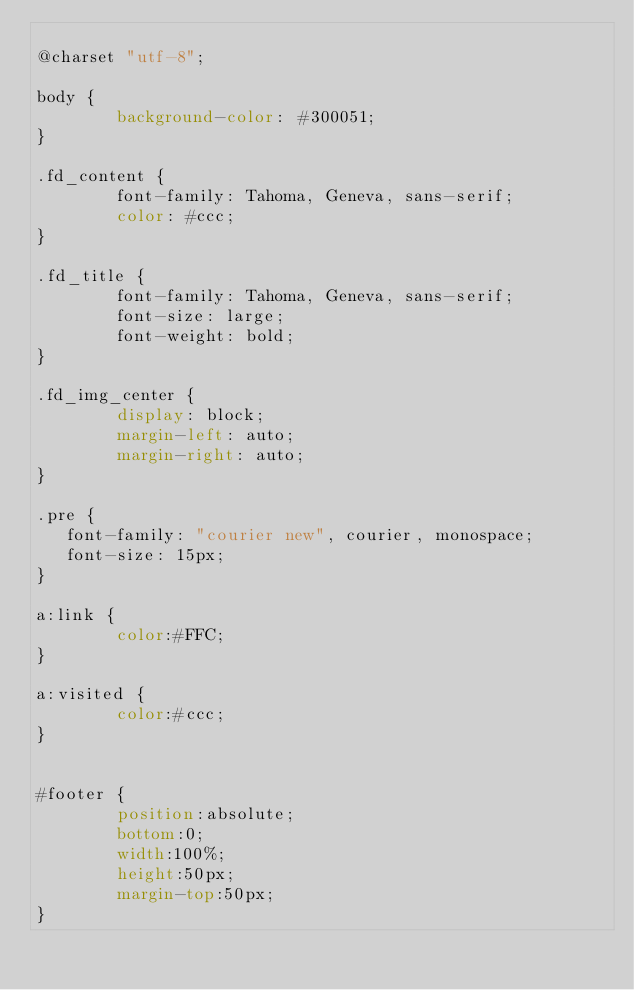<code> <loc_0><loc_0><loc_500><loc_500><_CSS_>
@charset "utf-8";

body {
        background-color: #300051;
}

.fd_content {
        font-family: Tahoma, Geneva, sans-serif;
        color: #ccc;
}

.fd_title {
        font-family: Tahoma, Geneva, sans-serif;
        font-size: large;
        font-weight: bold;
}

.fd_img_center {
        display: block;
        margin-left: auto;
        margin-right: auto;
}

.pre {
   font-family: "courier new", courier, monospace;
   font-size: 15px;
}

a:link {
        color:#FFC;
}

a:visited {
        color:#ccc;
}


#footer {
        position:absolute;
        bottom:0;
        width:100%;
        height:50px;
        margin-top:50px;
}


</code> 